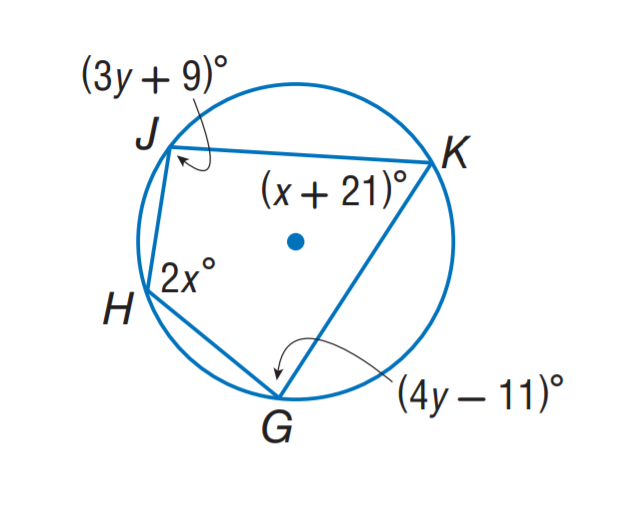Answer the mathemtical geometry problem and directly provide the correct option letter.
Question: Find m \angle G.
Choices: A: 93 B: 97 C: 106 D: 116 A 